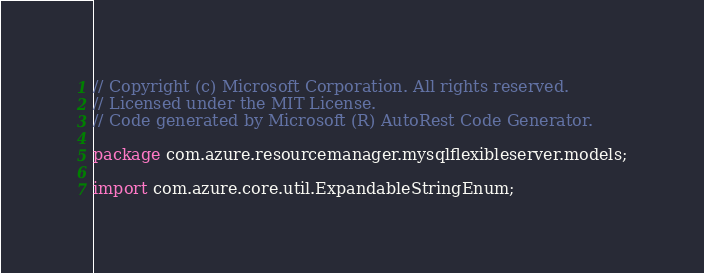<code> <loc_0><loc_0><loc_500><loc_500><_Java_>// Copyright (c) Microsoft Corporation. All rights reserved.
// Licensed under the MIT License.
// Code generated by Microsoft (R) AutoRest Code Generator.

package com.azure.resourcemanager.mysqlflexibleserver.models;

import com.azure.core.util.ExpandableStringEnum;</code> 